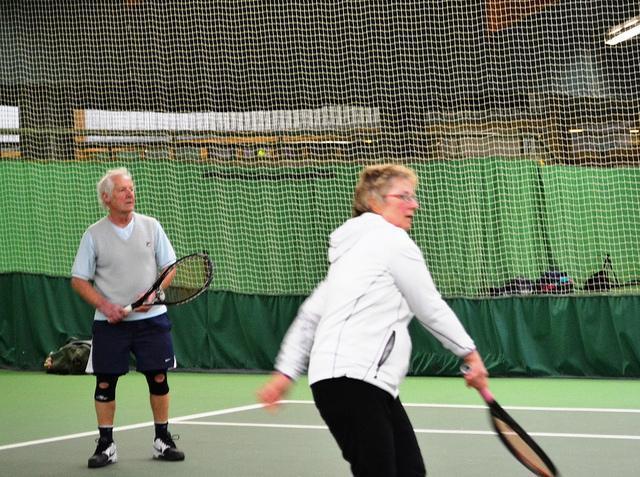How many tennis rackets are in the photo?
Give a very brief answer. 2. How many people can be seen?
Give a very brief answer. 2. 